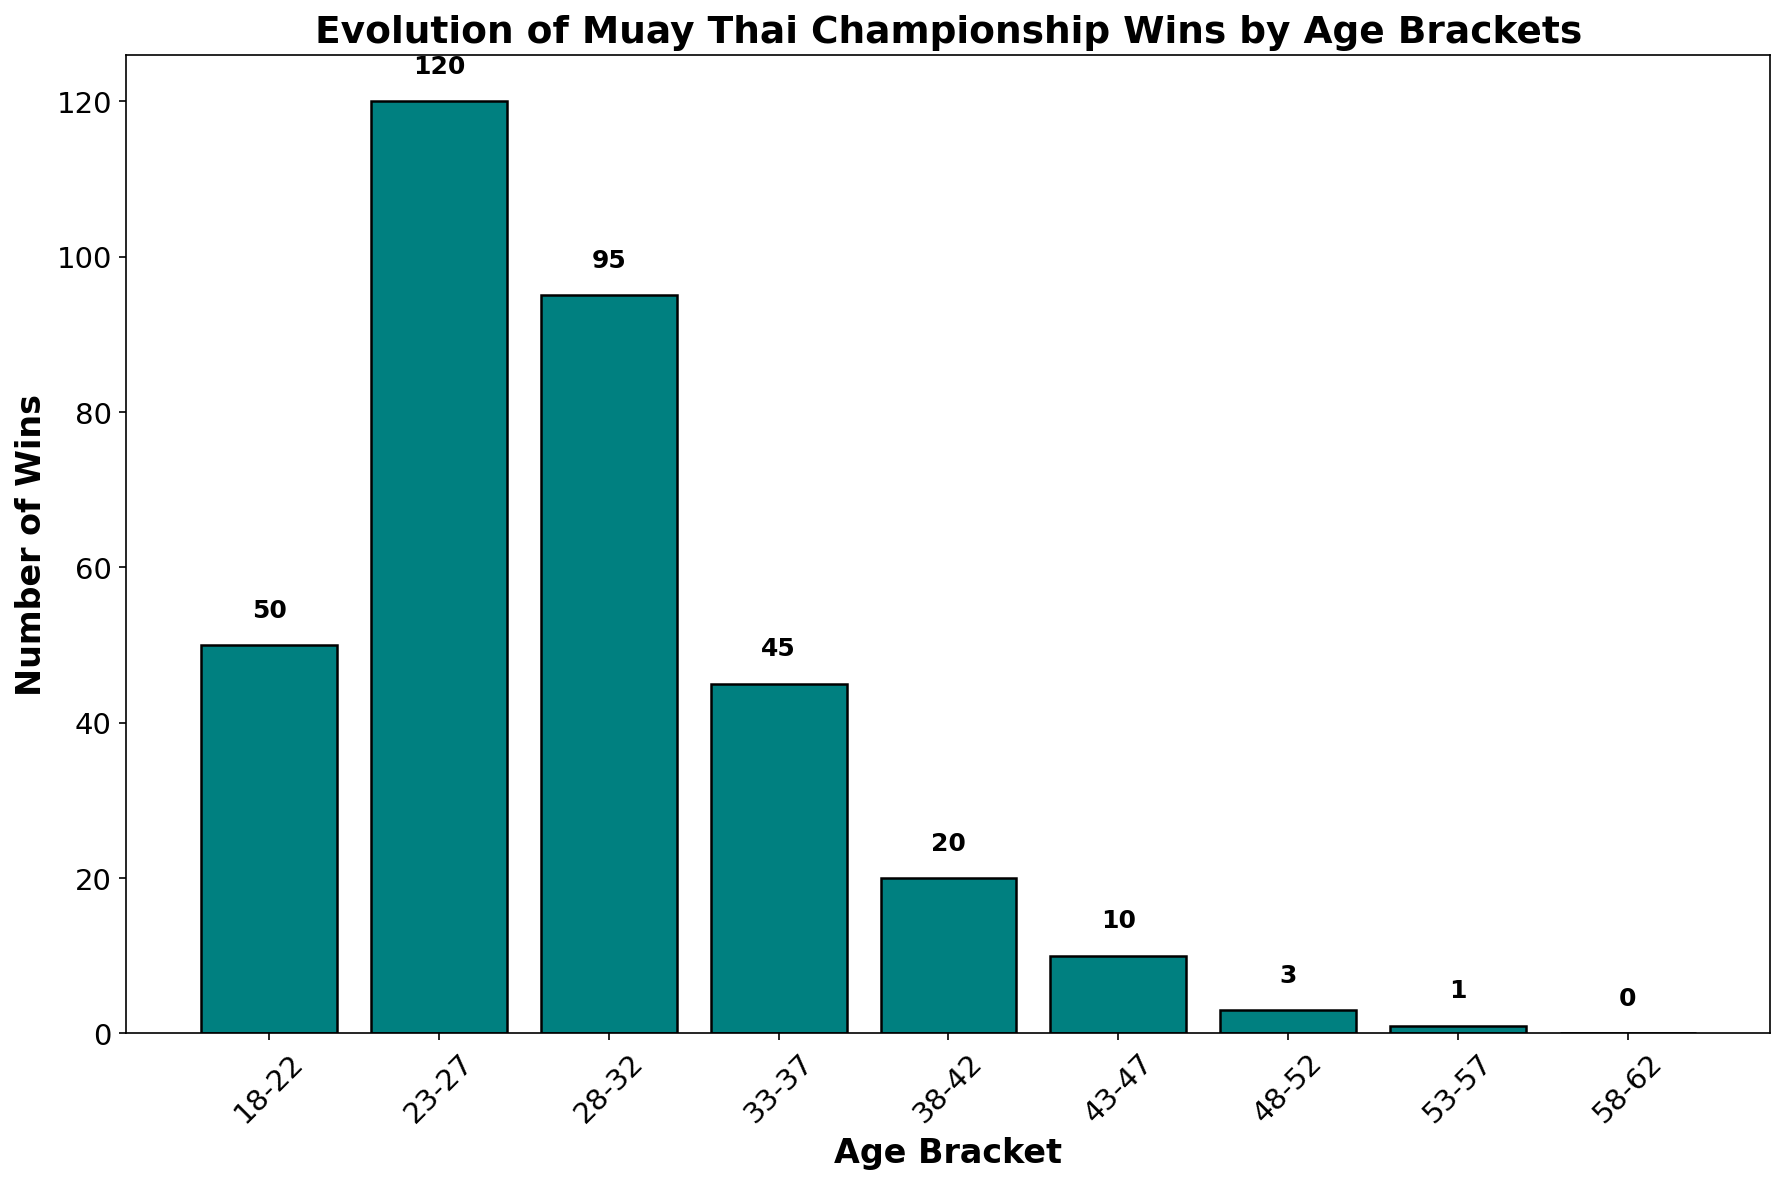What is the age bracket with the highest number of wins? The age bracket with the highest bar represents the highest number of wins. Age bracket 23-27 has the tallest bar, corresponding to 120 wins.
Answer: 23-27 How many more wins do fighters in the age bracket 23-27 have compared to those in the age bracket 33-37? Subtract the number of wins in the 33-37 bracket (45) from the number of wins in the 23-27 bracket (120): 120 - 45 = 75.
Answer: 75 What is the total number of wins for fighters aged 28 and above? Sum the number of wins for each age bracket starting from 28-32 to 58-62: 95 (28-32) + 45 (33-37) + 20 (38-42) + 10 (43-47) + 3 (48-52) + 1 (53-57) + 0 (58-62) = 174.
Answer: 174 Which two age brackets have wins that are equal or closest in number? Compare the number of wins for all age brackets, and find the closest values numerically: Age brackets 38-42 (20 wins) and 43-47 (10 wins) have a difference of 10, while age brackets 43-47 (10 wins) and 48-52 (3 wins) have a difference of only 7.
Answer: 43-47 and 48-52 What percentage of the total wins does the 23-27 age bracket represent? Calculate the total number of wins: 50 + 120 + 95 + 45 + 20 + 10 + 3 + 1 + 0 = 344. Then, find the percentage: (120 / 344) * 100 ≈ 34.88%.
Answer: ~34.88% How does the number of wins for fighters aged 48-52 compare to those aged 18-22? Compare the heights of the bars for the age brackets 18-22 (50 wins) and 48-52 (3 wins). Clearly, 50 is much greater than 3.
Answer: Fighters aged 18-22 have significantly more wins What is the noticeable trend in the number of wins as fighters age from 18 to 62? Observe the changes in the height of the bars from left to right. Wins increase from 18-22 to 23-27, then start to decline steadily from 28-32 onwards.
Answer: Wins initially increase, then steadily decline 